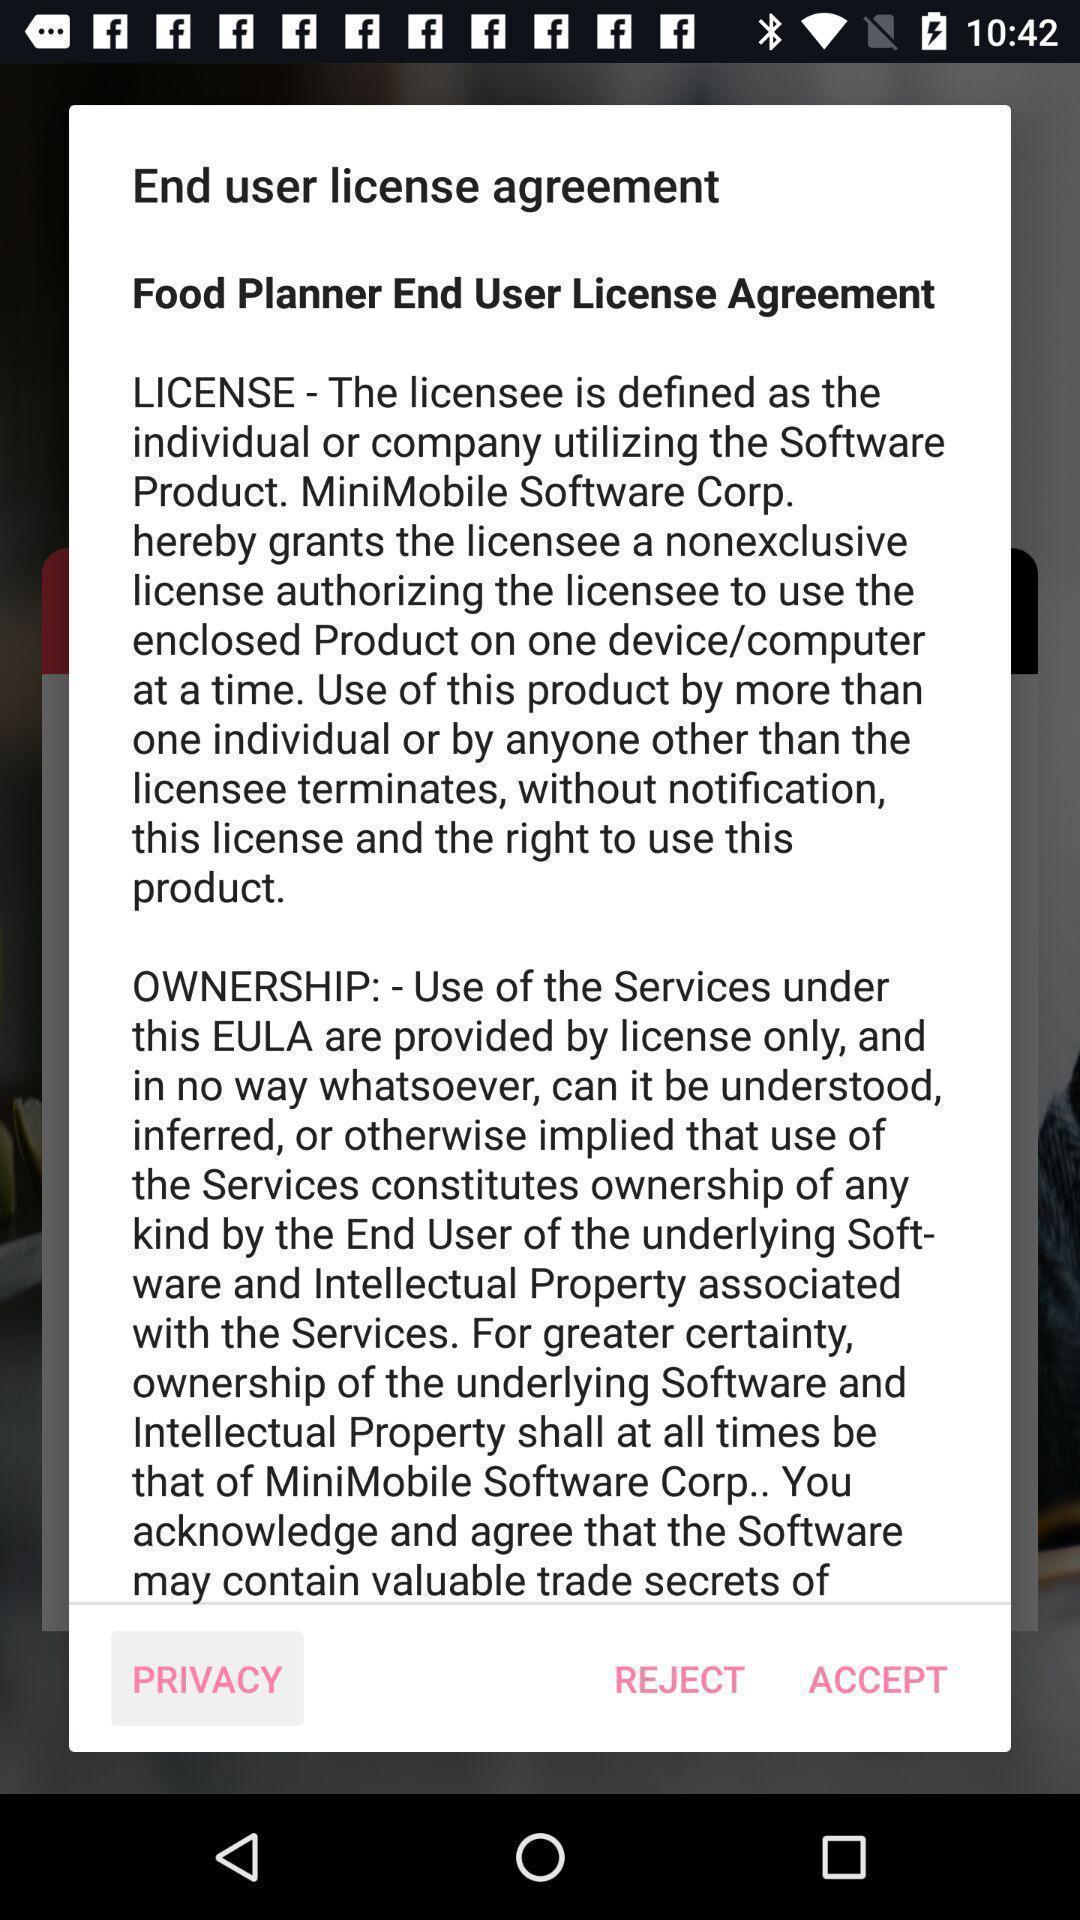Give me a narrative description of this picture. Pop-up showing the information of license agreement. 